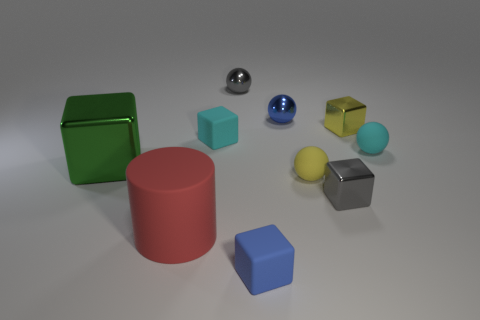Are the small yellow sphere and the cyan object to the right of the yellow matte object made of the same material?
Provide a short and direct response. Yes. There is a cyan object on the right side of the blue thing behind the big rubber object; what shape is it?
Your answer should be very brief. Sphere. How many tiny objects are either purple cylinders or blue metallic balls?
Provide a succinct answer. 1. What number of small yellow rubber objects have the same shape as the big rubber object?
Offer a very short reply. 0. There is a green thing; does it have the same shape as the tiny blue thing in front of the red object?
Keep it short and to the point. Yes. There is a gray block; what number of tiny gray shiny things are behind it?
Your response must be concise. 1. Are there any cubes that have the same size as the red thing?
Make the answer very short. Yes. Does the gray metal object in front of the big green thing have the same shape as the big metallic object?
Your answer should be compact. Yes. What color is the large shiny object?
Provide a succinct answer. Green. Are any yellow blocks visible?
Provide a succinct answer. Yes. 